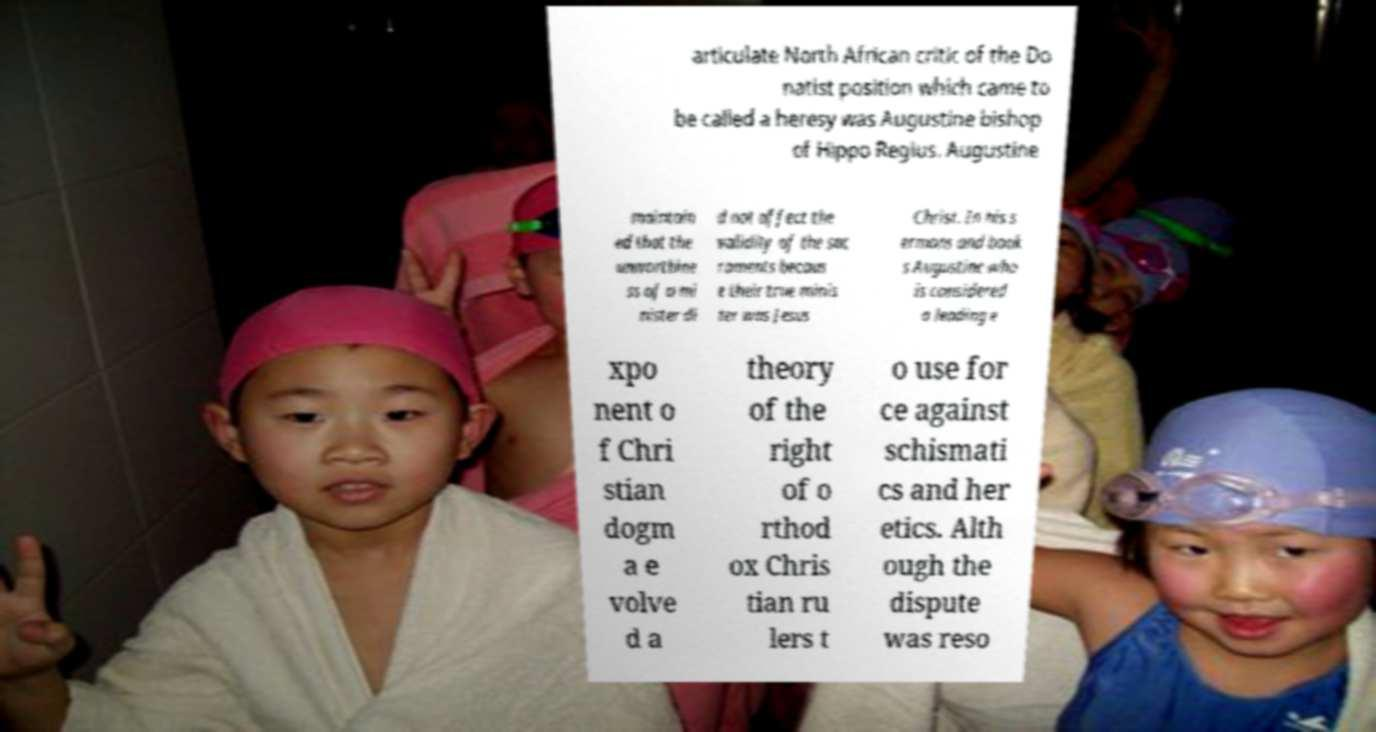What messages or text are displayed in this image? I need them in a readable, typed format. articulate North African critic of the Do natist position which came to be called a heresy was Augustine bishop of Hippo Regius. Augustine maintain ed that the unworthine ss of a mi nister di d not affect the validity of the sac raments becaus e their true minis ter was Jesus Christ. In his s ermons and book s Augustine who is considered a leading e xpo nent o f Chri stian dogm a e volve d a theory of the right of o rthod ox Chris tian ru lers t o use for ce against schismati cs and her etics. Alth ough the dispute was reso 